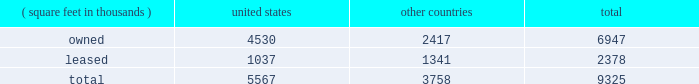Item 2 : properties information concerning applied 2019s properties is set forth below: .
Because of the interrelation of applied 2019s operations , properties within a country may be shared by the segments operating within that country .
The company 2019s headquarters offices are in santa clara , california .
Products in semiconductor systems are manufactured in santa clara , california ; austin , texas ; gloucester , massachusetts ; kalispell , montana ; rehovot , israel ; and singapore .
Remanufactured equipment products in the applied global services segment are produced primarily in austin , texas .
Products in the display and adjacent markets segment are manufactured in alzenau , germany and tainan , taiwan .
Other products are manufactured in treviso , italy .
Applied also owns and leases offices , plants and warehouse locations in many locations throughout the world , including in europe , japan , north america ( principally the united states ) , israel , china , india , korea , southeast asia and taiwan .
These facilities are principally used for manufacturing ; research , development and engineering ; and marketing , sales and customer support .
Applied also owns a total of approximately 269 acres of buildable land in montana , texas , california , israel and italy that could accommodate additional building space .
Applied considers the properties that it owns or leases as adequate to meet its current and future requirements .
Applied regularly assesses the size , capability and location of its global infrastructure and periodically makes adjustments based on these assessments. .
What portion of company's property is located in united states? 
Computations: (5567 / 9325)
Answer: 0.597. 